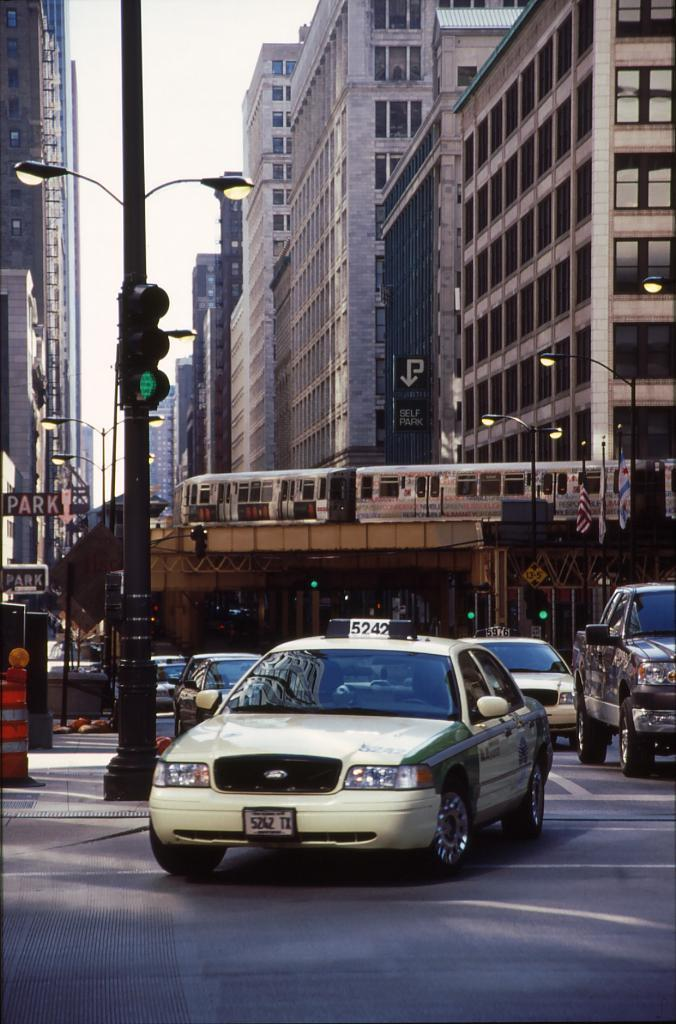<image>
Describe the image concisely. a taxi with the number 5242 on top of it 